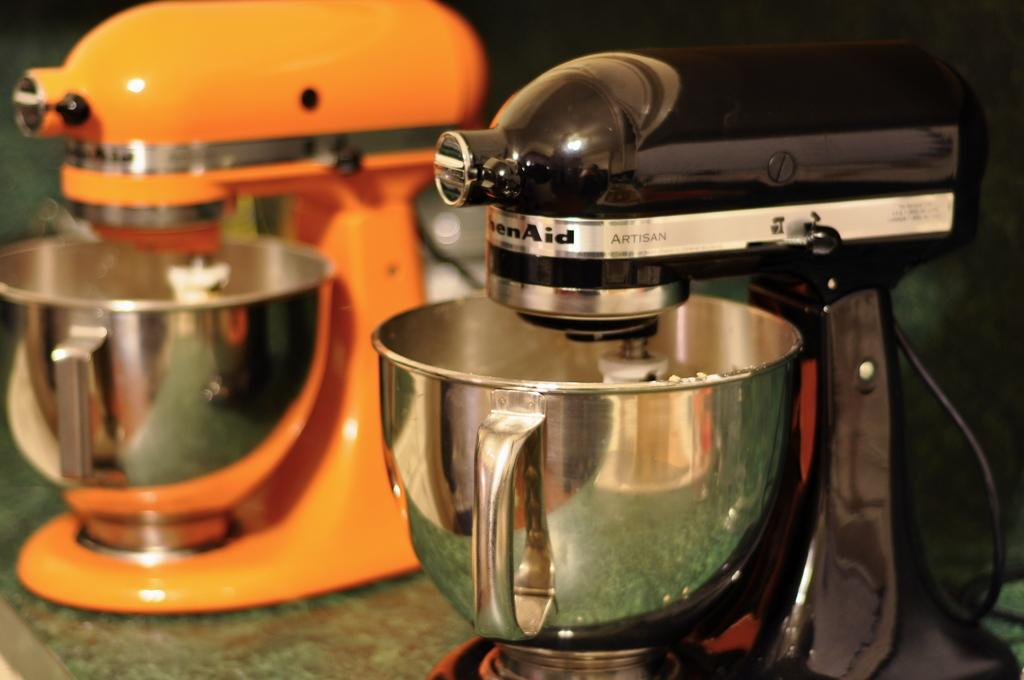<image>
Present a compact description of the photo's key features. Two blenders with the word Artisan written on the side 